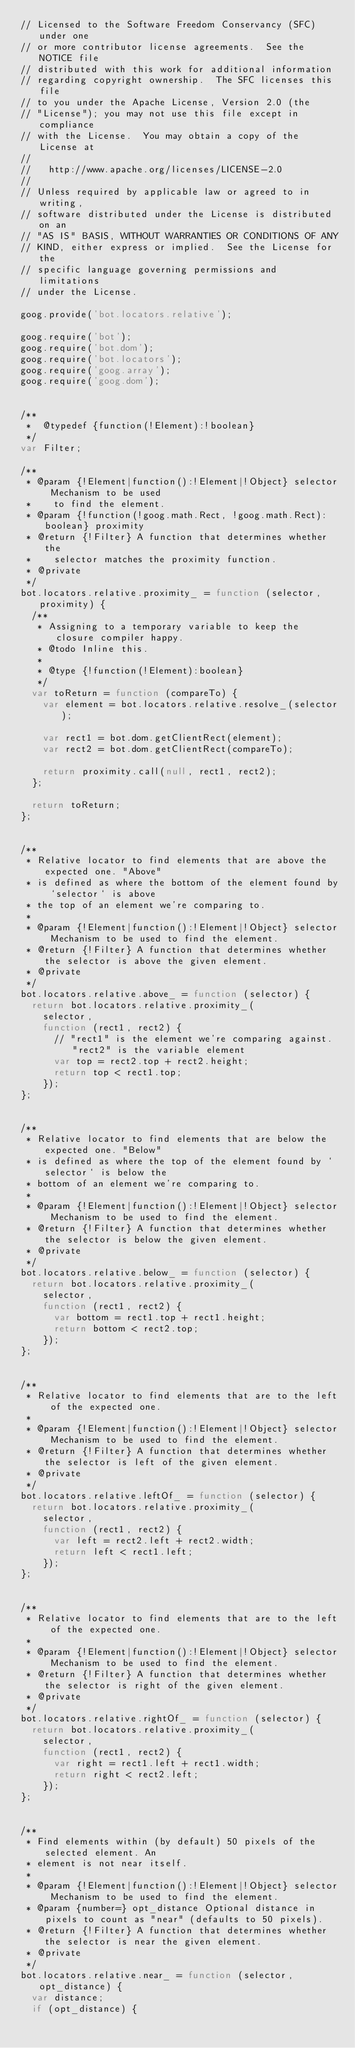Convert code to text. <code><loc_0><loc_0><loc_500><loc_500><_JavaScript_>// Licensed to the Software Freedom Conservancy (SFC) under one
// or more contributor license agreements.  See the NOTICE file
// distributed with this work for additional information
// regarding copyright ownership.  The SFC licenses this file
// to you under the Apache License, Version 2.0 (the
// "License"); you may not use this file except in compliance
// with the License.  You may obtain a copy of the License at
//
//   http://www.apache.org/licenses/LICENSE-2.0
//
// Unless required by applicable law or agreed to in writing,
// software distributed under the License is distributed on an
// "AS IS" BASIS, WITHOUT WARRANTIES OR CONDITIONS OF ANY
// KIND, either express or implied.  See the License for the
// specific language governing permissions and limitations
// under the License.

goog.provide('bot.locators.relative');

goog.require('bot');
goog.require('bot.dom');
goog.require('bot.locators');
goog.require('goog.array');
goog.require('goog.dom');


/**
 *  @typedef {function(!Element):!boolean}
 */
var Filter;

/**
 * @param {!Element|function():!Element|!Object} selector Mechanism to be used
 *    to find the element.
 * @param {!function(!goog.math.Rect, !goog.math.Rect):boolean} proximity
 * @return {!Filter} A function that determines whether the
 *    selector matches the proximity function.
 * @private
 */
bot.locators.relative.proximity_ = function (selector, proximity) {
  /**
   * Assigning to a temporary variable to keep the closure compiler happy.
   * @todo Inline this.
   *
   * @type {!function(!Element):boolean}
   */
  var toReturn = function (compareTo) {
    var element = bot.locators.relative.resolve_(selector);

    var rect1 = bot.dom.getClientRect(element);
    var rect2 = bot.dom.getClientRect(compareTo);

    return proximity.call(null, rect1, rect2);
  };

  return toReturn;
};


/**
 * Relative locator to find elements that are above the expected one. "Above"
 * is defined as where the bottom of the element found by `selector` is above
 * the top of an element we're comparing to.
 *
 * @param {!Element|function():!Element|!Object} selector Mechanism to be used to find the element.
 * @return {!Filter} A function that determines whether the selector is above the given element.
 * @private
 */
bot.locators.relative.above_ = function (selector) {
  return bot.locators.relative.proximity_(
    selector,
    function (rect1, rect2) {
      // "rect1" is the element we're comparing against. "rect2" is the variable element
      var top = rect2.top + rect2.height;
      return top < rect1.top;
    });
};


/**
 * Relative locator to find elements that are below the expected one. "Below"
 * is defined as where the top of the element found by `selector` is below the
 * bottom of an element we're comparing to.
 *
 * @param {!Element|function():!Element|!Object} selector Mechanism to be used to find the element.
 * @return {!Filter} A function that determines whether the selector is below the given element.
 * @private
 */
bot.locators.relative.below_ = function (selector) {
  return bot.locators.relative.proximity_(
    selector,
    function (rect1, rect2) {
      var bottom = rect1.top + rect1.height;
      return bottom < rect2.top;
    });
};


/**
 * Relative locator to find elements that are to the left of the expected one.
 *
 * @param {!Element|function():!Element|!Object} selector Mechanism to be used to find the element.
 * @return {!Filter} A function that determines whether the selector is left of the given element.
 * @private
 */
bot.locators.relative.leftOf_ = function (selector) {
  return bot.locators.relative.proximity_(
    selector,
    function (rect1, rect2) {
      var left = rect2.left + rect2.width;
      return left < rect1.left;
    });
};


/**
 * Relative locator to find elements that are to the left of the expected one.
 *
 * @param {!Element|function():!Element|!Object} selector Mechanism to be used to find the element.
 * @return {!Filter} A function that determines whether the selector is right of the given element.
 * @private
 */
bot.locators.relative.rightOf_ = function (selector) {
  return bot.locators.relative.proximity_(
    selector,
    function (rect1, rect2) {
      var right = rect1.left + rect1.width;
      return right < rect2.left;
    });
};


/**
 * Find elements within (by default) 50 pixels of the selected element. An
 * element is not near itself.
 *
 * @param {!Element|function():!Element|!Object} selector Mechanism to be used to find the element.
 * @param {number=} opt_distance Optional distance in pixels to count as "near" (defaults to 50 pixels).
 * @return {!Filter} A function that determines whether the selector is near the given element.
 * @private
 */
bot.locators.relative.near_ = function (selector, opt_distance) {
  var distance;
  if (opt_distance) {</code> 